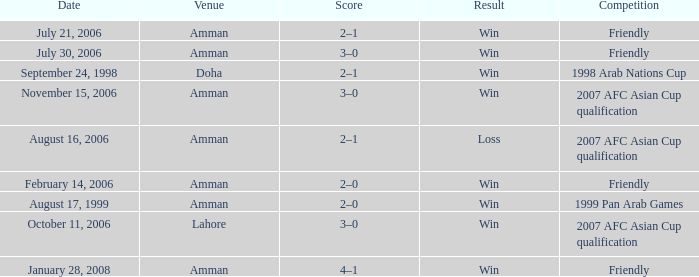Which competition took place on October 11, 2006? 2007 AFC Asian Cup qualification. 